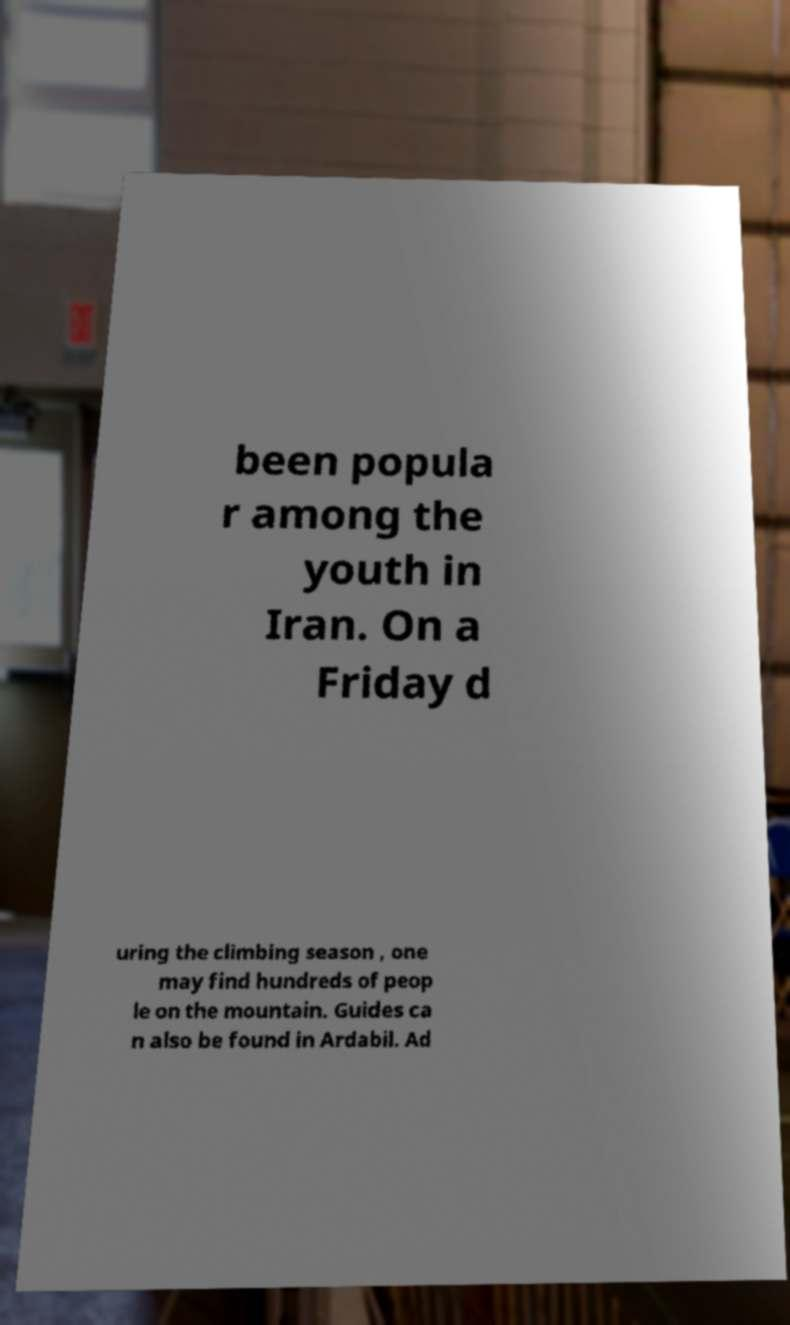For documentation purposes, I need the text within this image transcribed. Could you provide that? been popula r among the youth in Iran. On a Friday d uring the climbing season , one may find hundreds of peop le on the mountain. Guides ca n also be found in Ardabil. Ad 